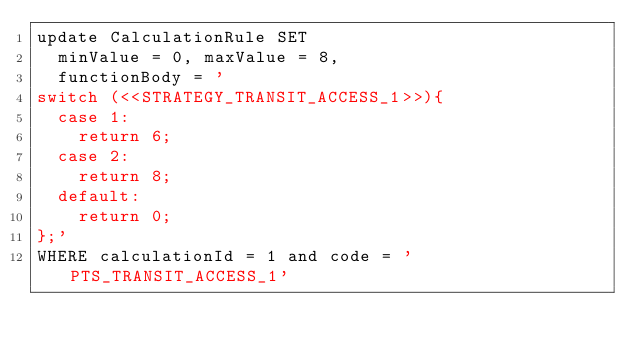Convert code to text. <code><loc_0><loc_0><loc_500><loc_500><_SQL_>update CalculationRule SET  
  minValue = 0, maxValue = 8,
  functionBody = ' 
switch (<<STRATEGY_TRANSIT_ACCESS_1>>){
	case 1:
		return 6;
	case 2:
		return 8;
	default:
		return 0;
};'
WHERE calculationId = 1 and code = 'PTS_TRANSIT_ACCESS_1'</code> 